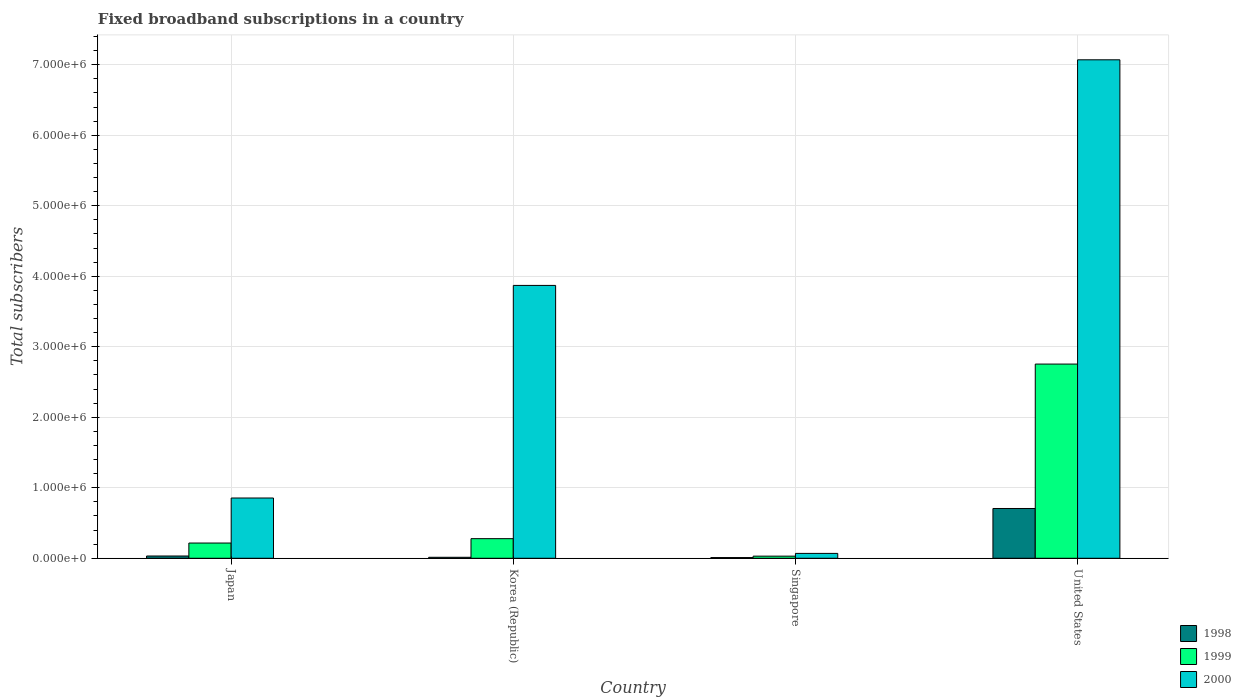What is the label of the 3rd group of bars from the left?
Make the answer very short. Singapore. In how many cases, is the number of bars for a given country not equal to the number of legend labels?
Give a very brief answer. 0. What is the number of broadband subscriptions in 1998 in Japan?
Provide a succinct answer. 3.20e+04. Across all countries, what is the maximum number of broadband subscriptions in 2000?
Your answer should be very brief. 7.07e+06. In which country was the number of broadband subscriptions in 1998 minimum?
Make the answer very short. Singapore. What is the total number of broadband subscriptions in 1999 in the graph?
Your response must be concise. 3.28e+06. What is the difference between the number of broadband subscriptions in 2000 in Japan and that in Singapore?
Your answer should be compact. 7.86e+05. What is the difference between the number of broadband subscriptions in 1998 in Singapore and the number of broadband subscriptions in 2000 in Korea (Republic)?
Offer a terse response. -3.86e+06. What is the average number of broadband subscriptions in 2000 per country?
Make the answer very short. 2.97e+06. What is the difference between the number of broadband subscriptions of/in 2000 and number of broadband subscriptions of/in 1998 in Korea (Republic)?
Your answer should be compact. 3.86e+06. What is the ratio of the number of broadband subscriptions in 2000 in Japan to that in United States?
Provide a succinct answer. 0.12. What is the difference between the highest and the second highest number of broadband subscriptions in 2000?
Offer a terse response. -3.20e+06. What is the difference between the highest and the lowest number of broadband subscriptions in 2000?
Offer a very short reply. 7.00e+06. In how many countries, is the number of broadband subscriptions in 2000 greater than the average number of broadband subscriptions in 2000 taken over all countries?
Your answer should be very brief. 2. What does the 2nd bar from the left in Korea (Republic) represents?
Ensure brevity in your answer.  1999. How many bars are there?
Provide a short and direct response. 12. Are all the bars in the graph horizontal?
Provide a succinct answer. No. Does the graph contain any zero values?
Give a very brief answer. No. Does the graph contain grids?
Provide a short and direct response. Yes. How many legend labels are there?
Provide a succinct answer. 3. What is the title of the graph?
Provide a short and direct response. Fixed broadband subscriptions in a country. Does "1976" appear as one of the legend labels in the graph?
Offer a terse response. No. What is the label or title of the X-axis?
Offer a terse response. Country. What is the label or title of the Y-axis?
Make the answer very short. Total subscribers. What is the Total subscribers in 1998 in Japan?
Provide a succinct answer. 3.20e+04. What is the Total subscribers of 1999 in Japan?
Give a very brief answer. 2.16e+05. What is the Total subscribers in 2000 in Japan?
Provide a short and direct response. 8.55e+05. What is the Total subscribers in 1998 in Korea (Republic)?
Your answer should be compact. 1.40e+04. What is the Total subscribers of 1999 in Korea (Republic)?
Keep it short and to the point. 2.78e+05. What is the Total subscribers in 2000 in Korea (Republic)?
Ensure brevity in your answer.  3.87e+06. What is the Total subscribers in 2000 in Singapore?
Provide a short and direct response. 6.90e+04. What is the Total subscribers of 1998 in United States?
Keep it short and to the point. 7.06e+05. What is the Total subscribers of 1999 in United States?
Your response must be concise. 2.75e+06. What is the Total subscribers in 2000 in United States?
Your answer should be compact. 7.07e+06. Across all countries, what is the maximum Total subscribers of 1998?
Your response must be concise. 7.06e+05. Across all countries, what is the maximum Total subscribers of 1999?
Your response must be concise. 2.75e+06. Across all countries, what is the maximum Total subscribers in 2000?
Provide a short and direct response. 7.07e+06. Across all countries, what is the minimum Total subscribers in 1998?
Ensure brevity in your answer.  10000. Across all countries, what is the minimum Total subscribers in 2000?
Provide a short and direct response. 6.90e+04. What is the total Total subscribers in 1998 in the graph?
Your response must be concise. 7.62e+05. What is the total Total subscribers of 1999 in the graph?
Your answer should be compact. 3.28e+06. What is the total Total subscribers of 2000 in the graph?
Make the answer very short. 1.19e+07. What is the difference between the Total subscribers in 1998 in Japan and that in Korea (Republic)?
Keep it short and to the point. 1.80e+04. What is the difference between the Total subscribers of 1999 in Japan and that in Korea (Republic)?
Your response must be concise. -6.20e+04. What is the difference between the Total subscribers of 2000 in Japan and that in Korea (Republic)?
Ensure brevity in your answer.  -3.02e+06. What is the difference between the Total subscribers of 1998 in Japan and that in Singapore?
Ensure brevity in your answer.  2.20e+04. What is the difference between the Total subscribers of 1999 in Japan and that in Singapore?
Make the answer very short. 1.86e+05. What is the difference between the Total subscribers of 2000 in Japan and that in Singapore?
Provide a short and direct response. 7.86e+05. What is the difference between the Total subscribers of 1998 in Japan and that in United States?
Provide a short and direct response. -6.74e+05. What is the difference between the Total subscribers of 1999 in Japan and that in United States?
Ensure brevity in your answer.  -2.54e+06. What is the difference between the Total subscribers in 2000 in Japan and that in United States?
Your response must be concise. -6.22e+06. What is the difference between the Total subscribers of 1998 in Korea (Republic) and that in Singapore?
Make the answer very short. 4000. What is the difference between the Total subscribers in 1999 in Korea (Republic) and that in Singapore?
Make the answer very short. 2.48e+05. What is the difference between the Total subscribers of 2000 in Korea (Republic) and that in Singapore?
Your answer should be compact. 3.80e+06. What is the difference between the Total subscribers in 1998 in Korea (Republic) and that in United States?
Provide a short and direct response. -6.92e+05. What is the difference between the Total subscribers in 1999 in Korea (Republic) and that in United States?
Offer a terse response. -2.48e+06. What is the difference between the Total subscribers of 2000 in Korea (Republic) and that in United States?
Your response must be concise. -3.20e+06. What is the difference between the Total subscribers of 1998 in Singapore and that in United States?
Keep it short and to the point. -6.96e+05. What is the difference between the Total subscribers in 1999 in Singapore and that in United States?
Offer a very short reply. -2.72e+06. What is the difference between the Total subscribers in 2000 in Singapore and that in United States?
Offer a very short reply. -7.00e+06. What is the difference between the Total subscribers of 1998 in Japan and the Total subscribers of 1999 in Korea (Republic)?
Your answer should be compact. -2.46e+05. What is the difference between the Total subscribers in 1998 in Japan and the Total subscribers in 2000 in Korea (Republic)?
Make the answer very short. -3.84e+06. What is the difference between the Total subscribers in 1999 in Japan and the Total subscribers in 2000 in Korea (Republic)?
Keep it short and to the point. -3.65e+06. What is the difference between the Total subscribers of 1998 in Japan and the Total subscribers of 1999 in Singapore?
Provide a succinct answer. 2000. What is the difference between the Total subscribers of 1998 in Japan and the Total subscribers of 2000 in Singapore?
Your answer should be very brief. -3.70e+04. What is the difference between the Total subscribers of 1999 in Japan and the Total subscribers of 2000 in Singapore?
Your answer should be very brief. 1.47e+05. What is the difference between the Total subscribers in 1998 in Japan and the Total subscribers in 1999 in United States?
Ensure brevity in your answer.  -2.72e+06. What is the difference between the Total subscribers of 1998 in Japan and the Total subscribers of 2000 in United States?
Make the answer very short. -7.04e+06. What is the difference between the Total subscribers of 1999 in Japan and the Total subscribers of 2000 in United States?
Your answer should be compact. -6.85e+06. What is the difference between the Total subscribers in 1998 in Korea (Republic) and the Total subscribers in 1999 in Singapore?
Your response must be concise. -1.60e+04. What is the difference between the Total subscribers in 1998 in Korea (Republic) and the Total subscribers in 2000 in Singapore?
Make the answer very short. -5.50e+04. What is the difference between the Total subscribers in 1999 in Korea (Republic) and the Total subscribers in 2000 in Singapore?
Offer a very short reply. 2.09e+05. What is the difference between the Total subscribers of 1998 in Korea (Republic) and the Total subscribers of 1999 in United States?
Provide a succinct answer. -2.74e+06. What is the difference between the Total subscribers in 1998 in Korea (Republic) and the Total subscribers in 2000 in United States?
Keep it short and to the point. -7.06e+06. What is the difference between the Total subscribers in 1999 in Korea (Republic) and the Total subscribers in 2000 in United States?
Make the answer very short. -6.79e+06. What is the difference between the Total subscribers in 1998 in Singapore and the Total subscribers in 1999 in United States?
Keep it short and to the point. -2.74e+06. What is the difference between the Total subscribers of 1998 in Singapore and the Total subscribers of 2000 in United States?
Your answer should be very brief. -7.06e+06. What is the difference between the Total subscribers of 1999 in Singapore and the Total subscribers of 2000 in United States?
Provide a short and direct response. -7.04e+06. What is the average Total subscribers in 1998 per country?
Provide a succinct answer. 1.90e+05. What is the average Total subscribers in 1999 per country?
Keep it short and to the point. 8.20e+05. What is the average Total subscribers of 2000 per country?
Your answer should be very brief. 2.97e+06. What is the difference between the Total subscribers in 1998 and Total subscribers in 1999 in Japan?
Offer a very short reply. -1.84e+05. What is the difference between the Total subscribers in 1998 and Total subscribers in 2000 in Japan?
Offer a very short reply. -8.23e+05. What is the difference between the Total subscribers of 1999 and Total subscribers of 2000 in Japan?
Provide a succinct answer. -6.39e+05. What is the difference between the Total subscribers in 1998 and Total subscribers in 1999 in Korea (Republic)?
Your response must be concise. -2.64e+05. What is the difference between the Total subscribers in 1998 and Total subscribers in 2000 in Korea (Republic)?
Offer a very short reply. -3.86e+06. What is the difference between the Total subscribers in 1999 and Total subscribers in 2000 in Korea (Republic)?
Your answer should be very brief. -3.59e+06. What is the difference between the Total subscribers in 1998 and Total subscribers in 1999 in Singapore?
Your answer should be compact. -2.00e+04. What is the difference between the Total subscribers in 1998 and Total subscribers in 2000 in Singapore?
Your response must be concise. -5.90e+04. What is the difference between the Total subscribers in 1999 and Total subscribers in 2000 in Singapore?
Make the answer very short. -3.90e+04. What is the difference between the Total subscribers of 1998 and Total subscribers of 1999 in United States?
Provide a succinct answer. -2.05e+06. What is the difference between the Total subscribers in 1998 and Total subscribers in 2000 in United States?
Your response must be concise. -6.36e+06. What is the difference between the Total subscribers in 1999 and Total subscribers in 2000 in United States?
Give a very brief answer. -4.32e+06. What is the ratio of the Total subscribers of 1998 in Japan to that in Korea (Republic)?
Your response must be concise. 2.29. What is the ratio of the Total subscribers of 1999 in Japan to that in Korea (Republic)?
Ensure brevity in your answer.  0.78. What is the ratio of the Total subscribers of 2000 in Japan to that in Korea (Republic)?
Offer a very short reply. 0.22. What is the ratio of the Total subscribers of 1998 in Japan to that in Singapore?
Your response must be concise. 3.2. What is the ratio of the Total subscribers in 2000 in Japan to that in Singapore?
Your answer should be compact. 12.39. What is the ratio of the Total subscribers in 1998 in Japan to that in United States?
Provide a succinct answer. 0.05. What is the ratio of the Total subscribers in 1999 in Japan to that in United States?
Ensure brevity in your answer.  0.08. What is the ratio of the Total subscribers in 2000 in Japan to that in United States?
Keep it short and to the point. 0.12. What is the ratio of the Total subscribers of 1999 in Korea (Republic) to that in Singapore?
Your response must be concise. 9.27. What is the ratio of the Total subscribers in 2000 in Korea (Republic) to that in Singapore?
Keep it short and to the point. 56.09. What is the ratio of the Total subscribers in 1998 in Korea (Republic) to that in United States?
Offer a very short reply. 0.02. What is the ratio of the Total subscribers of 1999 in Korea (Republic) to that in United States?
Offer a very short reply. 0.1. What is the ratio of the Total subscribers in 2000 in Korea (Republic) to that in United States?
Your answer should be very brief. 0.55. What is the ratio of the Total subscribers of 1998 in Singapore to that in United States?
Give a very brief answer. 0.01. What is the ratio of the Total subscribers of 1999 in Singapore to that in United States?
Your answer should be compact. 0.01. What is the ratio of the Total subscribers of 2000 in Singapore to that in United States?
Ensure brevity in your answer.  0.01. What is the difference between the highest and the second highest Total subscribers in 1998?
Your response must be concise. 6.74e+05. What is the difference between the highest and the second highest Total subscribers of 1999?
Offer a terse response. 2.48e+06. What is the difference between the highest and the second highest Total subscribers in 2000?
Provide a succinct answer. 3.20e+06. What is the difference between the highest and the lowest Total subscribers in 1998?
Keep it short and to the point. 6.96e+05. What is the difference between the highest and the lowest Total subscribers of 1999?
Provide a short and direct response. 2.72e+06. What is the difference between the highest and the lowest Total subscribers in 2000?
Make the answer very short. 7.00e+06. 